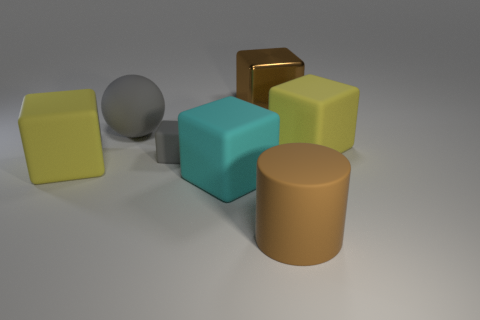Add 2 small purple objects. How many objects exist? 9 Subtract all matte blocks. How many blocks are left? 1 Subtract 3 cubes. How many cubes are left? 2 Subtract all cyan cubes. How many cubes are left? 4 Subtract all blue blocks. How many cyan cylinders are left? 0 Add 4 big spheres. How many big spheres are left? 5 Add 1 large cyan cubes. How many large cyan cubes exist? 2 Subtract 0 gray cylinders. How many objects are left? 7 Subtract all blocks. How many objects are left? 2 Subtract all yellow balls. Subtract all green cylinders. How many balls are left? 1 